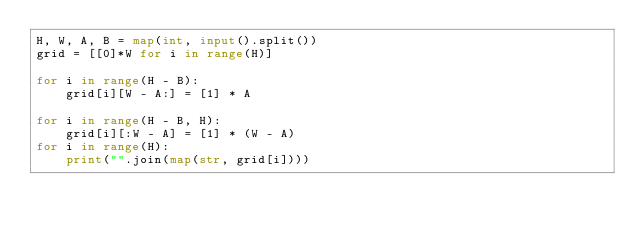<code> <loc_0><loc_0><loc_500><loc_500><_Python_>H, W, A, B = map(int, input().split())
grid = [[0]*W for i in range(H)]

for i in range(H - B):
    grid[i][W - A:] = [1] * A

for i in range(H - B, H):
    grid[i][:W - A] = [1] * (W - A)
for i in range(H):
    print("".join(map(str, grid[i])))
</code> 